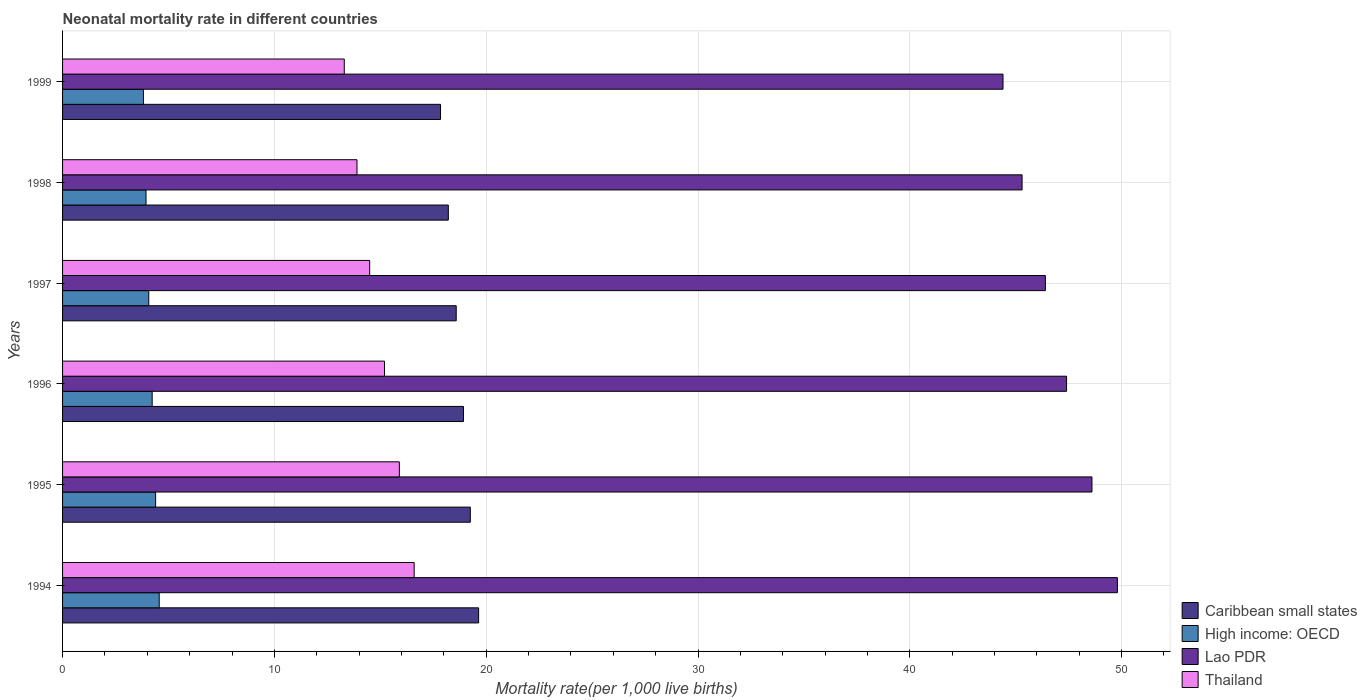How many different coloured bars are there?
Provide a succinct answer. 4. How many groups of bars are there?
Keep it short and to the point. 6. How many bars are there on the 5th tick from the top?
Keep it short and to the point. 4. How many bars are there on the 5th tick from the bottom?
Ensure brevity in your answer.  4. What is the neonatal mortality rate in High income: OECD in 1994?
Your answer should be compact. 4.56. Across all years, what is the maximum neonatal mortality rate in High income: OECD?
Keep it short and to the point. 4.56. Across all years, what is the minimum neonatal mortality rate in Caribbean small states?
Ensure brevity in your answer.  17.84. In which year was the neonatal mortality rate in High income: OECD minimum?
Offer a very short reply. 1999. What is the total neonatal mortality rate in Lao PDR in the graph?
Offer a terse response. 281.9. What is the difference between the neonatal mortality rate in High income: OECD in 1994 and that in 1999?
Your answer should be very brief. 0.75. What is the difference between the neonatal mortality rate in Lao PDR in 1996 and the neonatal mortality rate in Caribbean small states in 1997?
Provide a short and direct response. 28.81. What is the average neonatal mortality rate in Caribbean small states per year?
Offer a terse response. 18.74. In the year 1995, what is the difference between the neonatal mortality rate in Thailand and neonatal mortality rate in Caribbean small states?
Give a very brief answer. -3.35. In how many years, is the neonatal mortality rate in Caribbean small states greater than 26 ?
Offer a terse response. 0. What is the ratio of the neonatal mortality rate in High income: OECD in 1994 to that in 1998?
Your answer should be very brief. 1.16. Is the neonatal mortality rate in High income: OECD in 1995 less than that in 1998?
Provide a succinct answer. No. Is the difference between the neonatal mortality rate in Thailand in 1995 and 1997 greater than the difference between the neonatal mortality rate in Caribbean small states in 1995 and 1997?
Keep it short and to the point. Yes. What is the difference between the highest and the second highest neonatal mortality rate in Thailand?
Your answer should be very brief. 0.7. What is the difference between the highest and the lowest neonatal mortality rate in Lao PDR?
Make the answer very short. 5.4. In how many years, is the neonatal mortality rate in High income: OECD greater than the average neonatal mortality rate in High income: OECD taken over all years?
Offer a very short reply. 3. What does the 4th bar from the top in 1998 represents?
Make the answer very short. Caribbean small states. What does the 3rd bar from the bottom in 1996 represents?
Provide a short and direct response. Lao PDR. Is it the case that in every year, the sum of the neonatal mortality rate in Lao PDR and neonatal mortality rate in Thailand is greater than the neonatal mortality rate in High income: OECD?
Ensure brevity in your answer.  Yes. How many bars are there?
Provide a succinct answer. 24. What is the difference between two consecutive major ticks on the X-axis?
Give a very brief answer. 10. Are the values on the major ticks of X-axis written in scientific E-notation?
Provide a short and direct response. No. How many legend labels are there?
Offer a terse response. 4. What is the title of the graph?
Provide a succinct answer. Neonatal mortality rate in different countries. What is the label or title of the X-axis?
Offer a very short reply. Mortality rate(per 1,0 live births). What is the Mortality rate(per 1,000 live births) in Caribbean small states in 1994?
Ensure brevity in your answer.  19.64. What is the Mortality rate(per 1,000 live births) in High income: OECD in 1994?
Offer a very short reply. 4.56. What is the Mortality rate(per 1,000 live births) of Lao PDR in 1994?
Make the answer very short. 49.8. What is the Mortality rate(per 1,000 live births) of Caribbean small states in 1995?
Provide a succinct answer. 19.25. What is the Mortality rate(per 1,000 live births) of High income: OECD in 1995?
Give a very brief answer. 4.39. What is the Mortality rate(per 1,000 live births) in Lao PDR in 1995?
Provide a short and direct response. 48.6. What is the Mortality rate(per 1,000 live births) of Caribbean small states in 1996?
Keep it short and to the point. 18.93. What is the Mortality rate(per 1,000 live births) of High income: OECD in 1996?
Ensure brevity in your answer.  4.23. What is the Mortality rate(per 1,000 live births) in Lao PDR in 1996?
Your answer should be very brief. 47.4. What is the Mortality rate(per 1,000 live births) in Thailand in 1996?
Keep it short and to the point. 15.2. What is the Mortality rate(per 1,000 live births) of Caribbean small states in 1997?
Give a very brief answer. 18.59. What is the Mortality rate(per 1,000 live births) of High income: OECD in 1997?
Your answer should be very brief. 4.07. What is the Mortality rate(per 1,000 live births) in Lao PDR in 1997?
Offer a very short reply. 46.4. What is the Mortality rate(per 1,000 live births) of Caribbean small states in 1998?
Your answer should be very brief. 18.21. What is the Mortality rate(per 1,000 live births) of High income: OECD in 1998?
Your answer should be very brief. 3.94. What is the Mortality rate(per 1,000 live births) in Lao PDR in 1998?
Your answer should be very brief. 45.3. What is the Mortality rate(per 1,000 live births) of Caribbean small states in 1999?
Your answer should be very brief. 17.84. What is the Mortality rate(per 1,000 live births) in High income: OECD in 1999?
Your answer should be very brief. 3.82. What is the Mortality rate(per 1,000 live births) of Lao PDR in 1999?
Ensure brevity in your answer.  44.4. What is the Mortality rate(per 1,000 live births) of Thailand in 1999?
Give a very brief answer. 13.3. Across all years, what is the maximum Mortality rate(per 1,000 live births) of Caribbean small states?
Offer a terse response. 19.64. Across all years, what is the maximum Mortality rate(per 1,000 live births) of High income: OECD?
Make the answer very short. 4.56. Across all years, what is the maximum Mortality rate(per 1,000 live births) in Lao PDR?
Your answer should be very brief. 49.8. Across all years, what is the maximum Mortality rate(per 1,000 live births) in Thailand?
Provide a short and direct response. 16.6. Across all years, what is the minimum Mortality rate(per 1,000 live births) of Caribbean small states?
Offer a very short reply. 17.84. Across all years, what is the minimum Mortality rate(per 1,000 live births) in High income: OECD?
Keep it short and to the point. 3.82. Across all years, what is the minimum Mortality rate(per 1,000 live births) in Lao PDR?
Your answer should be compact. 44.4. What is the total Mortality rate(per 1,000 live births) in Caribbean small states in the graph?
Your answer should be compact. 112.46. What is the total Mortality rate(per 1,000 live births) of High income: OECD in the graph?
Provide a succinct answer. 25.01. What is the total Mortality rate(per 1,000 live births) of Lao PDR in the graph?
Your response must be concise. 281.9. What is the total Mortality rate(per 1,000 live births) in Thailand in the graph?
Make the answer very short. 89.4. What is the difference between the Mortality rate(per 1,000 live births) of Caribbean small states in 1994 and that in 1995?
Your response must be concise. 0.39. What is the difference between the Mortality rate(per 1,000 live births) of High income: OECD in 1994 and that in 1995?
Provide a short and direct response. 0.17. What is the difference between the Mortality rate(per 1,000 live births) in Caribbean small states in 1994 and that in 1996?
Provide a short and direct response. 0.72. What is the difference between the Mortality rate(per 1,000 live births) in High income: OECD in 1994 and that in 1996?
Provide a succinct answer. 0.33. What is the difference between the Mortality rate(per 1,000 live births) in Caribbean small states in 1994 and that in 1997?
Offer a terse response. 1.06. What is the difference between the Mortality rate(per 1,000 live births) of High income: OECD in 1994 and that in 1997?
Your response must be concise. 0.49. What is the difference between the Mortality rate(per 1,000 live births) of Lao PDR in 1994 and that in 1997?
Ensure brevity in your answer.  3.4. What is the difference between the Mortality rate(per 1,000 live births) in Caribbean small states in 1994 and that in 1998?
Give a very brief answer. 1.43. What is the difference between the Mortality rate(per 1,000 live births) in High income: OECD in 1994 and that in 1998?
Offer a terse response. 0.62. What is the difference between the Mortality rate(per 1,000 live births) in Lao PDR in 1994 and that in 1998?
Offer a very short reply. 4.5. What is the difference between the Mortality rate(per 1,000 live births) in Caribbean small states in 1994 and that in 1999?
Keep it short and to the point. 1.8. What is the difference between the Mortality rate(per 1,000 live births) of High income: OECD in 1994 and that in 1999?
Provide a succinct answer. 0.74. What is the difference between the Mortality rate(per 1,000 live births) in Lao PDR in 1994 and that in 1999?
Your response must be concise. 5.4. What is the difference between the Mortality rate(per 1,000 live births) in Caribbean small states in 1995 and that in 1996?
Provide a succinct answer. 0.32. What is the difference between the Mortality rate(per 1,000 live births) of High income: OECD in 1995 and that in 1996?
Your answer should be very brief. 0.16. What is the difference between the Mortality rate(per 1,000 live births) in Lao PDR in 1995 and that in 1996?
Provide a short and direct response. 1.2. What is the difference between the Mortality rate(per 1,000 live births) in Caribbean small states in 1995 and that in 1997?
Offer a terse response. 0.66. What is the difference between the Mortality rate(per 1,000 live births) in High income: OECD in 1995 and that in 1997?
Your answer should be compact. 0.32. What is the difference between the Mortality rate(per 1,000 live births) of Lao PDR in 1995 and that in 1997?
Your answer should be very brief. 2.2. What is the difference between the Mortality rate(per 1,000 live births) of Thailand in 1995 and that in 1997?
Make the answer very short. 1.4. What is the difference between the Mortality rate(per 1,000 live births) of Caribbean small states in 1995 and that in 1998?
Provide a succinct answer. 1.04. What is the difference between the Mortality rate(per 1,000 live births) in High income: OECD in 1995 and that in 1998?
Offer a terse response. 0.45. What is the difference between the Mortality rate(per 1,000 live births) of Lao PDR in 1995 and that in 1998?
Provide a short and direct response. 3.3. What is the difference between the Mortality rate(per 1,000 live births) of Caribbean small states in 1995 and that in 1999?
Give a very brief answer. 1.41. What is the difference between the Mortality rate(per 1,000 live births) of High income: OECD in 1995 and that in 1999?
Offer a terse response. 0.57. What is the difference between the Mortality rate(per 1,000 live births) of Lao PDR in 1995 and that in 1999?
Offer a terse response. 4.2. What is the difference between the Mortality rate(per 1,000 live births) in Caribbean small states in 1996 and that in 1997?
Keep it short and to the point. 0.34. What is the difference between the Mortality rate(per 1,000 live births) of High income: OECD in 1996 and that in 1997?
Give a very brief answer. 0.16. What is the difference between the Mortality rate(per 1,000 live births) in Lao PDR in 1996 and that in 1997?
Ensure brevity in your answer.  1. What is the difference between the Mortality rate(per 1,000 live births) in Caribbean small states in 1996 and that in 1998?
Offer a terse response. 0.72. What is the difference between the Mortality rate(per 1,000 live births) in High income: OECD in 1996 and that in 1998?
Keep it short and to the point. 0.29. What is the difference between the Mortality rate(per 1,000 live births) of Lao PDR in 1996 and that in 1998?
Give a very brief answer. 2.1. What is the difference between the Mortality rate(per 1,000 live births) in Caribbean small states in 1996 and that in 1999?
Your answer should be compact. 1.08. What is the difference between the Mortality rate(per 1,000 live births) of High income: OECD in 1996 and that in 1999?
Your answer should be very brief. 0.41. What is the difference between the Mortality rate(per 1,000 live births) in Lao PDR in 1996 and that in 1999?
Your answer should be compact. 3. What is the difference between the Mortality rate(per 1,000 live births) of Thailand in 1996 and that in 1999?
Offer a very short reply. 1.9. What is the difference between the Mortality rate(per 1,000 live births) in Caribbean small states in 1997 and that in 1998?
Offer a very short reply. 0.37. What is the difference between the Mortality rate(per 1,000 live births) in High income: OECD in 1997 and that in 1998?
Provide a succinct answer. 0.13. What is the difference between the Mortality rate(per 1,000 live births) in Lao PDR in 1997 and that in 1998?
Provide a short and direct response. 1.1. What is the difference between the Mortality rate(per 1,000 live births) in Thailand in 1997 and that in 1998?
Provide a succinct answer. 0.6. What is the difference between the Mortality rate(per 1,000 live births) of Caribbean small states in 1997 and that in 1999?
Your response must be concise. 0.74. What is the difference between the Mortality rate(per 1,000 live births) of High income: OECD in 1997 and that in 1999?
Keep it short and to the point. 0.25. What is the difference between the Mortality rate(per 1,000 live births) of Lao PDR in 1997 and that in 1999?
Your answer should be very brief. 2. What is the difference between the Mortality rate(per 1,000 live births) of Caribbean small states in 1998 and that in 1999?
Offer a very short reply. 0.37. What is the difference between the Mortality rate(per 1,000 live births) of High income: OECD in 1998 and that in 1999?
Your answer should be very brief. 0.12. What is the difference between the Mortality rate(per 1,000 live births) of Caribbean small states in 1994 and the Mortality rate(per 1,000 live births) of High income: OECD in 1995?
Keep it short and to the point. 15.25. What is the difference between the Mortality rate(per 1,000 live births) of Caribbean small states in 1994 and the Mortality rate(per 1,000 live births) of Lao PDR in 1995?
Your answer should be compact. -28.96. What is the difference between the Mortality rate(per 1,000 live births) in Caribbean small states in 1994 and the Mortality rate(per 1,000 live births) in Thailand in 1995?
Offer a terse response. 3.74. What is the difference between the Mortality rate(per 1,000 live births) of High income: OECD in 1994 and the Mortality rate(per 1,000 live births) of Lao PDR in 1995?
Your answer should be compact. -44.04. What is the difference between the Mortality rate(per 1,000 live births) in High income: OECD in 1994 and the Mortality rate(per 1,000 live births) in Thailand in 1995?
Your response must be concise. -11.34. What is the difference between the Mortality rate(per 1,000 live births) of Lao PDR in 1994 and the Mortality rate(per 1,000 live births) of Thailand in 1995?
Ensure brevity in your answer.  33.9. What is the difference between the Mortality rate(per 1,000 live births) in Caribbean small states in 1994 and the Mortality rate(per 1,000 live births) in High income: OECD in 1996?
Your answer should be compact. 15.41. What is the difference between the Mortality rate(per 1,000 live births) in Caribbean small states in 1994 and the Mortality rate(per 1,000 live births) in Lao PDR in 1996?
Provide a succinct answer. -27.76. What is the difference between the Mortality rate(per 1,000 live births) of Caribbean small states in 1994 and the Mortality rate(per 1,000 live births) of Thailand in 1996?
Provide a succinct answer. 4.44. What is the difference between the Mortality rate(per 1,000 live births) in High income: OECD in 1994 and the Mortality rate(per 1,000 live births) in Lao PDR in 1996?
Keep it short and to the point. -42.84. What is the difference between the Mortality rate(per 1,000 live births) of High income: OECD in 1994 and the Mortality rate(per 1,000 live births) of Thailand in 1996?
Your answer should be very brief. -10.64. What is the difference between the Mortality rate(per 1,000 live births) in Lao PDR in 1994 and the Mortality rate(per 1,000 live births) in Thailand in 1996?
Give a very brief answer. 34.6. What is the difference between the Mortality rate(per 1,000 live births) in Caribbean small states in 1994 and the Mortality rate(per 1,000 live births) in High income: OECD in 1997?
Offer a terse response. 15.57. What is the difference between the Mortality rate(per 1,000 live births) of Caribbean small states in 1994 and the Mortality rate(per 1,000 live births) of Lao PDR in 1997?
Make the answer very short. -26.76. What is the difference between the Mortality rate(per 1,000 live births) in Caribbean small states in 1994 and the Mortality rate(per 1,000 live births) in Thailand in 1997?
Provide a succinct answer. 5.14. What is the difference between the Mortality rate(per 1,000 live births) in High income: OECD in 1994 and the Mortality rate(per 1,000 live births) in Lao PDR in 1997?
Your response must be concise. -41.84. What is the difference between the Mortality rate(per 1,000 live births) of High income: OECD in 1994 and the Mortality rate(per 1,000 live births) of Thailand in 1997?
Your response must be concise. -9.94. What is the difference between the Mortality rate(per 1,000 live births) in Lao PDR in 1994 and the Mortality rate(per 1,000 live births) in Thailand in 1997?
Provide a short and direct response. 35.3. What is the difference between the Mortality rate(per 1,000 live births) in Caribbean small states in 1994 and the Mortality rate(per 1,000 live births) in High income: OECD in 1998?
Your answer should be compact. 15.7. What is the difference between the Mortality rate(per 1,000 live births) in Caribbean small states in 1994 and the Mortality rate(per 1,000 live births) in Lao PDR in 1998?
Your answer should be compact. -25.66. What is the difference between the Mortality rate(per 1,000 live births) of Caribbean small states in 1994 and the Mortality rate(per 1,000 live births) of Thailand in 1998?
Provide a short and direct response. 5.74. What is the difference between the Mortality rate(per 1,000 live births) in High income: OECD in 1994 and the Mortality rate(per 1,000 live births) in Lao PDR in 1998?
Give a very brief answer. -40.74. What is the difference between the Mortality rate(per 1,000 live births) in High income: OECD in 1994 and the Mortality rate(per 1,000 live births) in Thailand in 1998?
Make the answer very short. -9.34. What is the difference between the Mortality rate(per 1,000 live births) of Lao PDR in 1994 and the Mortality rate(per 1,000 live births) of Thailand in 1998?
Provide a short and direct response. 35.9. What is the difference between the Mortality rate(per 1,000 live births) in Caribbean small states in 1994 and the Mortality rate(per 1,000 live births) in High income: OECD in 1999?
Offer a terse response. 15.83. What is the difference between the Mortality rate(per 1,000 live births) of Caribbean small states in 1994 and the Mortality rate(per 1,000 live births) of Lao PDR in 1999?
Offer a terse response. -24.76. What is the difference between the Mortality rate(per 1,000 live births) of Caribbean small states in 1994 and the Mortality rate(per 1,000 live births) of Thailand in 1999?
Your answer should be compact. 6.34. What is the difference between the Mortality rate(per 1,000 live births) in High income: OECD in 1994 and the Mortality rate(per 1,000 live births) in Lao PDR in 1999?
Your answer should be compact. -39.84. What is the difference between the Mortality rate(per 1,000 live births) in High income: OECD in 1994 and the Mortality rate(per 1,000 live births) in Thailand in 1999?
Give a very brief answer. -8.74. What is the difference between the Mortality rate(per 1,000 live births) in Lao PDR in 1994 and the Mortality rate(per 1,000 live births) in Thailand in 1999?
Offer a very short reply. 36.5. What is the difference between the Mortality rate(per 1,000 live births) of Caribbean small states in 1995 and the Mortality rate(per 1,000 live births) of High income: OECD in 1996?
Offer a very short reply. 15.02. What is the difference between the Mortality rate(per 1,000 live births) in Caribbean small states in 1995 and the Mortality rate(per 1,000 live births) in Lao PDR in 1996?
Your answer should be compact. -28.15. What is the difference between the Mortality rate(per 1,000 live births) of Caribbean small states in 1995 and the Mortality rate(per 1,000 live births) of Thailand in 1996?
Give a very brief answer. 4.05. What is the difference between the Mortality rate(per 1,000 live births) in High income: OECD in 1995 and the Mortality rate(per 1,000 live births) in Lao PDR in 1996?
Keep it short and to the point. -43.01. What is the difference between the Mortality rate(per 1,000 live births) in High income: OECD in 1995 and the Mortality rate(per 1,000 live births) in Thailand in 1996?
Offer a terse response. -10.81. What is the difference between the Mortality rate(per 1,000 live births) of Lao PDR in 1995 and the Mortality rate(per 1,000 live births) of Thailand in 1996?
Give a very brief answer. 33.4. What is the difference between the Mortality rate(per 1,000 live births) of Caribbean small states in 1995 and the Mortality rate(per 1,000 live births) of High income: OECD in 1997?
Ensure brevity in your answer.  15.18. What is the difference between the Mortality rate(per 1,000 live births) of Caribbean small states in 1995 and the Mortality rate(per 1,000 live births) of Lao PDR in 1997?
Provide a succinct answer. -27.15. What is the difference between the Mortality rate(per 1,000 live births) of Caribbean small states in 1995 and the Mortality rate(per 1,000 live births) of Thailand in 1997?
Your response must be concise. 4.75. What is the difference between the Mortality rate(per 1,000 live births) in High income: OECD in 1995 and the Mortality rate(per 1,000 live births) in Lao PDR in 1997?
Your answer should be compact. -42.01. What is the difference between the Mortality rate(per 1,000 live births) of High income: OECD in 1995 and the Mortality rate(per 1,000 live births) of Thailand in 1997?
Offer a very short reply. -10.11. What is the difference between the Mortality rate(per 1,000 live births) in Lao PDR in 1995 and the Mortality rate(per 1,000 live births) in Thailand in 1997?
Keep it short and to the point. 34.1. What is the difference between the Mortality rate(per 1,000 live births) of Caribbean small states in 1995 and the Mortality rate(per 1,000 live births) of High income: OECD in 1998?
Make the answer very short. 15.31. What is the difference between the Mortality rate(per 1,000 live births) of Caribbean small states in 1995 and the Mortality rate(per 1,000 live births) of Lao PDR in 1998?
Make the answer very short. -26.05. What is the difference between the Mortality rate(per 1,000 live births) of Caribbean small states in 1995 and the Mortality rate(per 1,000 live births) of Thailand in 1998?
Make the answer very short. 5.35. What is the difference between the Mortality rate(per 1,000 live births) of High income: OECD in 1995 and the Mortality rate(per 1,000 live births) of Lao PDR in 1998?
Offer a very short reply. -40.91. What is the difference between the Mortality rate(per 1,000 live births) of High income: OECD in 1995 and the Mortality rate(per 1,000 live births) of Thailand in 1998?
Offer a terse response. -9.51. What is the difference between the Mortality rate(per 1,000 live births) in Lao PDR in 1995 and the Mortality rate(per 1,000 live births) in Thailand in 1998?
Keep it short and to the point. 34.7. What is the difference between the Mortality rate(per 1,000 live births) of Caribbean small states in 1995 and the Mortality rate(per 1,000 live births) of High income: OECD in 1999?
Your response must be concise. 15.43. What is the difference between the Mortality rate(per 1,000 live births) of Caribbean small states in 1995 and the Mortality rate(per 1,000 live births) of Lao PDR in 1999?
Offer a terse response. -25.15. What is the difference between the Mortality rate(per 1,000 live births) of Caribbean small states in 1995 and the Mortality rate(per 1,000 live births) of Thailand in 1999?
Offer a very short reply. 5.95. What is the difference between the Mortality rate(per 1,000 live births) of High income: OECD in 1995 and the Mortality rate(per 1,000 live births) of Lao PDR in 1999?
Offer a very short reply. -40.01. What is the difference between the Mortality rate(per 1,000 live births) in High income: OECD in 1995 and the Mortality rate(per 1,000 live births) in Thailand in 1999?
Give a very brief answer. -8.91. What is the difference between the Mortality rate(per 1,000 live births) in Lao PDR in 1995 and the Mortality rate(per 1,000 live births) in Thailand in 1999?
Provide a short and direct response. 35.3. What is the difference between the Mortality rate(per 1,000 live births) in Caribbean small states in 1996 and the Mortality rate(per 1,000 live births) in High income: OECD in 1997?
Your response must be concise. 14.86. What is the difference between the Mortality rate(per 1,000 live births) of Caribbean small states in 1996 and the Mortality rate(per 1,000 live births) of Lao PDR in 1997?
Your answer should be very brief. -27.47. What is the difference between the Mortality rate(per 1,000 live births) of Caribbean small states in 1996 and the Mortality rate(per 1,000 live births) of Thailand in 1997?
Make the answer very short. 4.43. What is the difference between the Mortality rate(per 1,000 live births) in High income: OECD in 1996 and the Mortality rate(per 1,000 live births) in Lao PDR in 1997?
Ensure brevity in your answer.  -42.17. What is the difference between the Mortality rate(per 1,000 live births) in High income: OECD in 1996 and the Mortality rate(per 1,000 live births) in Thailand in 1997?
Offer a very short reply. -10.27. What is the difference between the Mortality rate(per 1,000 live births) of Lao PDR in 1996 and the Mortality rate(per 1,000 live births) of Thailand in 1997?
Ensure brevity in your answer.  32.9. What is the difference between the Mortality rate(per 1,000 live births) in Caribbean small states in 1996 and the Mortality rate(per 1,000 live births) in High income: OECD in 1998?
Ensure brevity in your answer.  14.99. What is the difference between the Mortality rate(per 1,000 live births) of Caribbean small states in 1996 and the Mortality rate(per 1,000 live births) of Lao PDR in 1998?
Keep it short and to the point. -26.37. What is the difference between the Mortality rate(per 1,000 live births) in Caribbean small states in 1996 and the Mortality rate(per 1,000 live births) in Thailand in 1998?
Provide a short and direct response. 5.03. What is the difference between the Mortality rate(per 1,000 live births) of High income: OECD in 1996 and the Mortality rate(per 1,000 live births) of Lao PDR in 1998?
Your answer should be compact. -41.07. What is the difference between the Mortality rate(per 1,000 live births) in High income: OECD in 1996 and the Mortality rate(per 1,000 live births) in Thailand in 1998?
Ensure brevity in your answer.  -9.67. What is the difference between the Mortality rate(per 1,000 live births) of Lao PDR in 1996 and the Mortality rate(per 1,000 live births) of Thailand in 1998?
Ensure brevity in your answer.  33.5. What is the difference between the Mortality rate(per 1,000 live births) in Caribbean small states in 1996 and the Mortality rate(per 1,000 live births) in High income: OECD in 1999?
Your answer should be very brief. 15.11. What is the difference between the Mortality rate(per 1,000 live births) in Caribbean small states in 1996 and the Mortality rate(per 1,000 live births) in Lao PDR in 1999?
Keep it short and to the point. -25.47. What is the difference between the Mortality rate(per 1,000 live births) in Caribbean small states in 1996 and the Mortality rate(per 1,000 live births) in Thailand in 1999?
Ensure brevity in your answer.  5.63. What is the difference between the Mortality rate(per 1,000 live births) in High income: OECD in 1996 and the Mortality rate(per 1,000 live births) in Lao PDR in 1999?
Offer a very short reply. -40.17. What is the difference between the Mortality rate(per 1,000 live births) in High income: OECD in 1996 and the Mortality rate(per 1,000 live births) in Thailand in 1999?
Your answer should be compact. -9.07. What is the difference between the Mortality rate(per 1,000 live births) in Lao PDR in 1996 and the Mortality rate(per 1,000 live births) in Thailand in 1999?
Provide a short and direct response. 34.1. What is the difference between the Mortality rate(per 1,000 live births) of Caribbean small states in 1997 and the Mortality rate(per 1,000 live births) of High income: OECD in 1998?
Your response must be concise. 14.65. What is the difference between the Mortality rate(per 1,000 live births) of Caribbean small states in 1997 and the Mortality rate(per 1,000 live births) of Lao PDR in 1998?
Provide a short and direct response. -26.71. What is the difference between the Mortality rate(per 1,000 live births) in Caribbean small states in 1997 and the Mortality rate(per 1,000 live births) in Thailand in 1998?
Provide a short and direct response. 4.69. What is the difference between the Mortality rate(per 1,000 live births) in High income: OECD in 1997 and the Mortality rate(per 1,000 live births) in Lao PDR in 1998?
Offer a very short reply. -41.23. What is the difference between the Mortality rate(per 1,000 live births) of High income: OECD in 1997 and the Mortality rate(per 1,000 live births) of Thailand in 1998?
Your response must be concise. -9.83. What is the difference between the Mortality rate(per 1,000 live births) of Lao PDR in 1997 and the Mortality rate(per 1,000 live births) of Thailand in 1998?
Provide a short and direct response. 32.5. What is the difference between the Mortality rate(per 1,000 live births) in Caribbean small states in 1997 and the Mortality rate(per 1,000 live births) in High income: OECD in 1999?
Give a very brief answer. 14.77. What is the difference between the Mortality rate(per 1,000 live births) in Caribbean small states in 1997 and the Mortality rate(per 1,000 live births) in Lao PDR in 1999?
Keep it short and to the point. -25.81. What is the difference between the Mortality rate(per 1,000 live births) in Caribbean small states in 1997 and the Mortality rate(per 1,000 live births) in Thailand in 1999?
Ensure brevity in your answer.  5.29. What is the difference between the Mortality rate(per 1,000 live births) of High income: OECD in 1997 and the Mortality rate(per 1,000 live births) of Lao PDR in 1999?
Provide a succinct answer. -40.33. What is the difference between the Mortality rate(per 1,000 live births) of High income: OECD in 1997 and the Mortality rate(per 1,000 live births) of Thailand in 1999?
Keep it short and to the point. -9.23. What is the difference between the Mortality rate(per 1,000 live births) of Lao PDR in 1997 and the Mortality rate(per 1,000 live births) of Thailand in 1999?
Keep it short and to the point. 33.1. What is the difference between the Mortality rate(per 1,000 live births) in Caribbean small states in 1998 and the Mortality rate(per 1,000 live births) in High income: OECD in 1999?
Provide a short and direct response. 14.39. What is the difference between the Mortality rate(per 1,000 live births) in Caribbean small states in 1998 and the Mortality rate(per 1,000 live births) in Lao PDR in 1999?
Your answer should be very brief. -26.19. What is the difference between the Mortality rate(per 1,000 live births) in Caribbean small states in 1998 and the Mortality rate(per 1,000 live births) in Thailand in 1999?
Your answer should be very brief. 4.91. What is the difference between the Mortality rate(per 1,000 live births) in High income: OECD in 1998 and the Mortality rate(per 1,000 live births) in Lao PDR in 1999?
Offer a terse response. -40.46. What is the difference between the Mortality rate(per 1,000 live births) in High income: OECD in 1998 and the Mortality rate(per 1,000 live births) in Thailand in 1999?
Make the answer very short. -9.36. What is the difference between the Mortality rate(per 1,000 live births) of Lao PDR in 1998 and the Mortality rate(per 1,000 live births) of Thailand in 1999?
Offer a very short reply. 32. What is the average Mortality rate(per 1,000 live births) in Caribbean small states per year?
Your answer should be compact. 18.74. What is the average Mortality rate(per 1,000 live births) in High income: OECD per year?
Offer a terse response. 4.17. What is the average Mortality rate(per 1,000 live births) of Lao PDR per year?
Provide a succinct answer. 46.98. What is the average Mortality rate(per 1,000 live births) of Thailand per year?
Your answer should be very brief. 14.9. In the year 1994, what is the difference between the Mortality rate(per 1,000 live births) in Caribbean small states and Mortality rate(per 1,000 live births) in High income: OECD?
Your answer should be compact. 15.08. In the year 1994, what is the difference between the Mortality rate(per 1,000 live births) in Caribbean small states and Mortality rate(per 1,000 live births) in Lao PDR?
Keep it short and to the point. -30.16. In the year 1994, what is the difference between the Mortality rate(per 1,000 live births) in Caribbean small states and Mortality rate(per 1,000 live births) in Thailand?
Give a very brief answer. 3.04. In the year 1994, what is the difference between the Mortality rate(per 1,000 live births) of High income: OECD and Mortality rate(per 1,000 live births) of Lao PDR?
Offer a terse response. -45.24. In the year 1994, what is the difference between the Mortality rate(per 1,000 live births) in High income: OECD and Mortality rate(per 1,000 live births) in Thailand?
Ensure brevity in your answer.  -12.04. In the year 1994, what is the difference between the Mortality rate(per 1,000 live births) of Lao PDR and Mortality rate(per 1,000 live births) of Thailand?
Your response must be concise. 33.2. In the year 1995, what is the difference between the Mortality rate(per 1,000 live births) in Caribbean small states and Mortality rate(per 1,000 live births) in High income: OECD?
Provide a short and direct response. 14.86. In the year 1995, what is the difference between the Mortality rate(per 1,000 live births) of Caribbean small states and Mortality rate(per 1,000 live births) of Lao PDR?
Offer a very short reply. -29.35. In the year 1995, what is the difference between the Mortality rate(per 1,000 live births) of Caribbean small states and Mortality rate(per 1,000 live births) of Thailand?
Keep it short and to the point. 3.35. In the year 1995, what is the difference between the Mortality rate(per 1,000 live births) in High income: OECD and Mortality rate(per 1,000 live births) in Lao PDR?
Your answer should be very brief. -44.21. In the year 1995, what is the difference between the Mortality rate(per 1,000 live births) of High income: OECD and Mortality rate(per 1,000 live births) of Thailand?
Offer a terse response. -11.51. In the year 1995, what is the difference between the Mortality rate(per 1,000 live births) in Lao PDR and Mortality rate(per 1,000 live births) in Thailand?
Provide a succinct answer. 32.7. In the year 1996, what is the difference between the Mortality rate(per 1,000 live births) of Caribbean small states and Mortality rate(per 1,000 live births) of High income: OECD?
Provide a short and direct response. 14.7. In the year 1996, what is the difference between the Mortality rate(per 1,000 live births) of Caribbean small states and Mortality rate(per 1,000 live births) of Lao PDR?
Offer a terse response. -28.47. In the year 1996, what is the difference between the Mortality rate(per 1,000 live births) in Caribbean small states and Mortality rate(per 1,000 live births) in Thailand?
Offer a terse response. 3.73. In the year 1996, what is the difference between the Mortality rate(per 1,000 live births) of High income: OECD and Mortality rate(per 1,000 live births) of Lao PDR?
Your answer should be compact. -43.17. In the year 1996, what is the difference between the Mortality rate(per 1,000 live births) in High income: OECD and Mortality rate(per 1,000 live births) in Thailand?
Keep it short and to the point. -10.97. In the year 1996, what is the difference between the Mortality rate(per 1,000 live births) in Lao PDR and Mortality rate(per 1,000 live births) in Thailand?
Provide a succinct answer. 32.2. In the year 1997, what is the difference between the Mortality rate(per 1,000 live births) of Caribbean small states and Mortality rate(per 1,000 live births) of High income: OECD?
Your response must be concise. 14.52. In the year 1997, what is the difference between the Mortality rate(per 1,000 live births) of Caribbean small states and Mortality rate(per 1,000 live births) of Lao PDR?
Offer a terse response. -27.81. In the year 1997, what is the difference between the Mortality rate(per 1,000 live births) in Caribbean small states and Mortality rate(per 1,000 live births) in Thailand?
Offer a terse response. 4.09. In the year 1997, what is the difference between the Mortality rate(per 1,000 live births) of High income: OECD and Mortality rate(per 1,000 live births) of Lao PDR?
Your answer should be very brief. -42.33. In the year 1997, what is the difference between the Mortality rate(per 1,000 live births) of High income: OECD and Mortality rate(per 1,000 live births) of Thailand?
Ensure brevity in your answer.  -10.43. In the year 1997, what is the difference between the Mortality rate(per 1,000 live births) of Lao PDR and Mortality rate(per 1,000 live births) of Thailand?
Your response must be concise. 31.9. In the year 1998, what is the difference between the Mortality rate(per 1,000 live births) in Caribbean small states and Mortality rate(per 1,000 live births) in High income: OECD?
Your response must be concise. 14.27. In the year 1998, what is the difference between the Mortality rate(per 1,000 live births) of Caribbean small states and Mortality rate(per 1,000 live births) of Lao PDR?
Keep it short and to the point. -27.09. In the year 1998, what is the difference between the Mortality rate(per 1,000 live births) in Caribbean small states and Mortality rate(per 1,000 live births) in Thailand?
Keep it short and to the point. 4.31. In the year 1998, what is the difference between the Mortality rate(per 1,000 live births) in High income: OECD and Mortality rate(per 1,000 live births) in Lao PDR?
Offer a terse response. -41.36. In the year 1998, what is the difference between the Mortality rate(per 1,000 live births) of High income: OECD and Mortality rate(per 1,000 live births) of Thailand?
Offer a very short reply. -9.96. In the year 1998, what is the difference between the Mortality rate(per 1,000 live births) in Lao PDR and Mortality rate(per 1,000 live births) in Thailand?
Offer a terse response. 31.4. In the year 1999, what is the difference between the Mortality rate(per 1,000 live births) of Caribbean small states and Mortality rate(per 1,000 live births) of High income: OECD?
Your answer should be very brief. 14.03. In the year 1999, what is the difference between the Mortality rate(per 1,000 live births) of Caribbean small states and Mortality rate(per 1,000 live births) of Lao PDR?
Your response must be concise. -26.56. In the year 1999, what is the difference between the Mortality rate(per 1,000 live births) of Caribbean small states and Mortality rate(per 1,000 live births) of Thailand?
Offer a very short reply. 4.54. In the year 1999, what is the difference between the Mortality rate(per 1,000 live births) of High income: OECD and Mortality rate(per 1,000 live births) of Lao PDR?
Provide a short and direct response. -40.58. In the year 1999, what is the difference between the Mortality rate(per 1,000 live births) of High income: OECD and Mortality rate(per 1,000 live births) of Thailand?
Ensure brevity in your answer.  -9.48. In the year 1999, what is the difference between the Mortality rate(per 1,000 live births) of Lao PDR and Mortality rate(per 1,000 live births) of Thailand?
Your answer should be very brief. 31.1. What is the ratio of the Mortality rate(per 1,000 live births) of Caribbean small states in 1994 to that in 1995?
Give a very brief answer. 1.02. What is the ratio of the Mortality rate(per 1,000 live births) in High income: OECD in 1994 to that in 1995?
Your response must be concise. 1.04. What is the ratio of the Mortality rate(per 1,000 live births) of Lao PDR in 1994 to that in 1995?
Your answer should be compact. 1.02. What is the ratio of the Mortality rate(per 1,000 live births) in Thailand in 1994 to that in 1995?
Keep it short and to the point. 1.04. What is the ratio of the Mortality rate(per 1,000 live births) of Caribbean small states in 1994 to that in 1996?
Your answer should be very brief. 1.04. What is the ratio of the Mortality rate(per 1,000 live births) in High income: OECD in 1994 to that in 1996?
Keep it short and to the point. 1.08. What is the ratio of the Mortality rate(per 1,000 live births) of Lao PDR in 1994 to that in 1996?
Make the answer very short. 1.05. What is the ratio of the Mortality rate(per 1,000 live births) in Thailand in 1994 to that in 1996?
Offer a terse response. 1.09. What is the ratio of the Mortality rate(per 1,000 live births) of Caribbean small states in 1994 to that in 1997?
Your response must be concise. 1.06. What is the ratio of the Mortality rate(per 1,000 live births) in High income: OECD in 1994 to that in 1997?
Your response must be concise. 1.12. What is the ratio of the Mortality rate(per 1,000 live births) in Lao PDR in 1994 to that in 1997?
Make the answer very short. 1.07. What is the ratio of the Mortality rate(per 1,000 live births) in Thailand in 1994 to that in 1997?
Ensure brevity in your answer.  1.14. What is the ratio of the Mortality rate(per 1,000 live births) of Caribbean small states in 1994 to that in 1998?
Provide a succinct answer. 1.08. What is the ratio of the Mortality rate(per 1,000 live births) in High income: OECD in 1994 to that in 1998?
Your answer should be compact. 1.16. What is the ratio of the Mortality rate(per 1,000 live births) in Lao PDR in 1994 to that in 1998?
Provide a short and direct response. 1.1. What is the ratio of the Mortality rate(per 1,000 live births) of Thailand in 1994 to that in 1998?
Your response must be concise. 1.19. What is the ratio of the Mortality rate(per 1,000 live births) of Caribbean small states in 1994 to that in 1999?
Your response must be concise. 1.1. What is the ratio of the Mortality rate(per 1,000 live births) of High income: OECD in 1994 to that in 1999?
Provide a succinct answer. 1.2. What is the ratio of the Mortality rate(per 1,000 live births) of Lao PDR in 1994 to that in 1999?
Keep it short and to the point. 1.12. What is the ratio of the Mortality rate(per 1,000 live births) in Thailand in 1994 to that in 1999?
Your answer should be compact. 1.25. What is the ratio of the Mortality rate(per 1,000 live births) of High income: OECD in 1995 to that in 1996?
Your response must be concise. 1.04. What is the ratio of the Mortality rate(per 1,000 live births) of Lao PDR in 1995 to that in 1996?
Ensure brevity in your answer.  1.03. What is the ratio of the Mortality rate(per 1,000 live births) of Thailand in 1995 to that in 1996?
Provide a short and direct response. 1.05. What is the ratio of the Mortality rate(per 1,000 live births) of Caribbean small states in 1995 to that in 1997?
Offer a very short reply. 1.04. What is the ratio of the Mortality rate(per 1,000 live births) in High income: OECD in 1995 to that in 1997?
Offer a very short reply. 1.08. What is the ratio of the Mortality rate(per 1,000 live births) of Lao PDR in 1995 to that in 1997?
Provide a succinct answer. 1.05. What is the ratio of the Mortality rate(per 1,000 live births) of Thailand in 1995 to that in 1997?
Your answer should be compact. 1.1. What is the ratio of the Mortality rate(per 1,000 live births) in Caribbean small states in 1995 to that in 1998?
Make the answer very short. 1.06. What is the ratio of the Mortality rate(per 1,000 live births) in High income: OECD in 1995 to that in 1998?
Your response must be concise. 1.11. What is the ratio of the Mortality rate(per 1,000 live births) of Lao PDR in 1995 to that in 1998?
Ensure brevity in your answer.  1.07. What is the ratio of the Mortality rate(per 1,000 live births) in Thailand in 1995 to that in 1998?
Your answer should be very brief. 1.14. What is the ratio of the Mortality rate(per 1,000 live births) in Caribbean small states in 1995 to that in 1999?
Provide a short and direct response. 1.08. What is the ratio of the Mortality rate(per 1,000 live births) in High income: OECD in 1995 to that in 1999?
Your response must be concise. 1.15. What is the ratio of the Mortality rate(per 1,000 live births) of Lao PDR in 1995 to that in 1999?
Your answer should be very brief. 1.09. What is the ratio of the Mortality rate(per 1,000 live births) in Thailand in 1995 to that in 1999?
Give a very brief answer. 1.2. What is the ratio of the Mortality rate(per 1,000 live births) in Caribbean small states in 1996 to that in 1997?
Your response must be concise. 1.02. What is the ratio of the Mortality rate(per 1,000 live births) of High income: OECD in 1996 to that in 1997?
Your response must be concise. 1.04. What is the ratio of the Mortality rate(per 1,000 live births) of Lao PDR in 1996 to that in 1997?
Your response must be concise. 1.02. What is the ratio of the Mortality rate(per 1,000 live births) of Thailand in 1996 to that in 1997?
Provide a short and direct response. 1.05. What is the ratio of the Mortality rate(per 1,000 live births) of Caribbean small states in 1996 to that in 1998?
Offer a very short reply. 1.04. What is the ratio of the Mortality rate(per 1,000 live births) in High income: OECD in 1996 to that in 1998?
Give a very brief answer. 1.07. What is the ratio of the Mortality rate(per 1,000 live births) of Lao PDR in 1996 to that in 1998?
Keep it short and to the point. 1.05. What is the ratio of the Mortality rate(per 1,000 live births) in Thailand in 1996 to that in 1998?
Offer a very short reply. 1.09. What is the ratio of the Mortality rate(per 1,000 live births) of Caribbean small states in 1996 to that in 1999?
Offer a terse response. 1.06. What is the ratio of the Mortality rate(per 1,000 live births) of High income: OECD in 1996 to that in 1999?
Give a very brief answer. 1.11. What is the ratio of the Mortality rate(per 1,000 live births) in Lao PDR in 1996 to that in 1999?
Offer a very short reply. 1.07. What is the ratio of the Mortality rate(per 1,000 live births) of Thailand in 1996 to that in 1999?
Your response must be concise. 1.14. What is the ratio of the Mortality rate(per 1,000 live births) in Caribbean small states in 1997 to that in 1998?
Your answer should be very brief. 1.02. What is the ratio of the Mortality rate(per 1,000 live births) in High income: OECD in 1997 to that in 1998?
Ensure brevity in your answer.  1.03. What is the ratio of the Mortality rate(per 1,000 live births) of Lao PDR in 1997 to that in 1998?
Offer a terse response. 1.02. What is the ratio of the Mortality rate(per 1,000 live births) of Thailand in 1997 to that in 1998?
Offer a terse response. 1.04. What is the ratio of the Mortality rate(per 1,000 live births) of Caribbean small states in 1997 to that in 1999?
Provide a succinct answer. 1.04. What is the ratio of the Mortality rate(per 1,000 live births) of High income: OECD in 1997 to that in 1999?
Your answer should be very brief. 1.07. What is the ratio of the Mortality rate(per 1,000 live births) in Lao PDR in 1997 to that in 1999?
Provide a succinct answer. 1.04. What is the ratio of the Mortality rate(per 1,000 live births) of Thailand in 1997 to that in 1999?
Keep it short and to the point. 1.09. What is the ratio of the Mortality rate(per 1,000 live births) of Caribbean small states in 1998 to that in 1999?
Provide a short and direct response. 1.02. What is the ratio of the Mortality rate(per 1,000 live births) in High income: OECD in 1998 to that in 1999?
Provide a short and direct response. 1.03. What is the ratio of the Mortality rate(per 1,000 live births) in Lao PDR in 1998 to that in 1999?
Make the answer very short. 1.02. What is the ratio of the Mortality rate(per 1,000 live births) in Thailand in 1998 to that in 1999?
Provide a short and direct response. 1.05. What is the difference between the highest and the second highest Mortality rate(per 1,000 live births) in Caribbean small states?
Give a very brief answer. 0.39. What is the difference between the highest and the second highest Mortality rate(per 1,000 live births) of High income: OECD?
Offer a very short reply. 0.17. What is the difference between the highest and the second highest Mortality rate(per 1,000 live births) in Lao PDR?
Your answer should be very brief. 1.2. What is the difference between the highest and the lowest Mortality rate(per 1,000 live births) in Caribbean small states?
Provide a succinct answer. 1.8. What is the difference between the highest and the lowest Mortality rate(per 1,000 live births) of High income: OECD?
Make the answer very short. 0.74. 